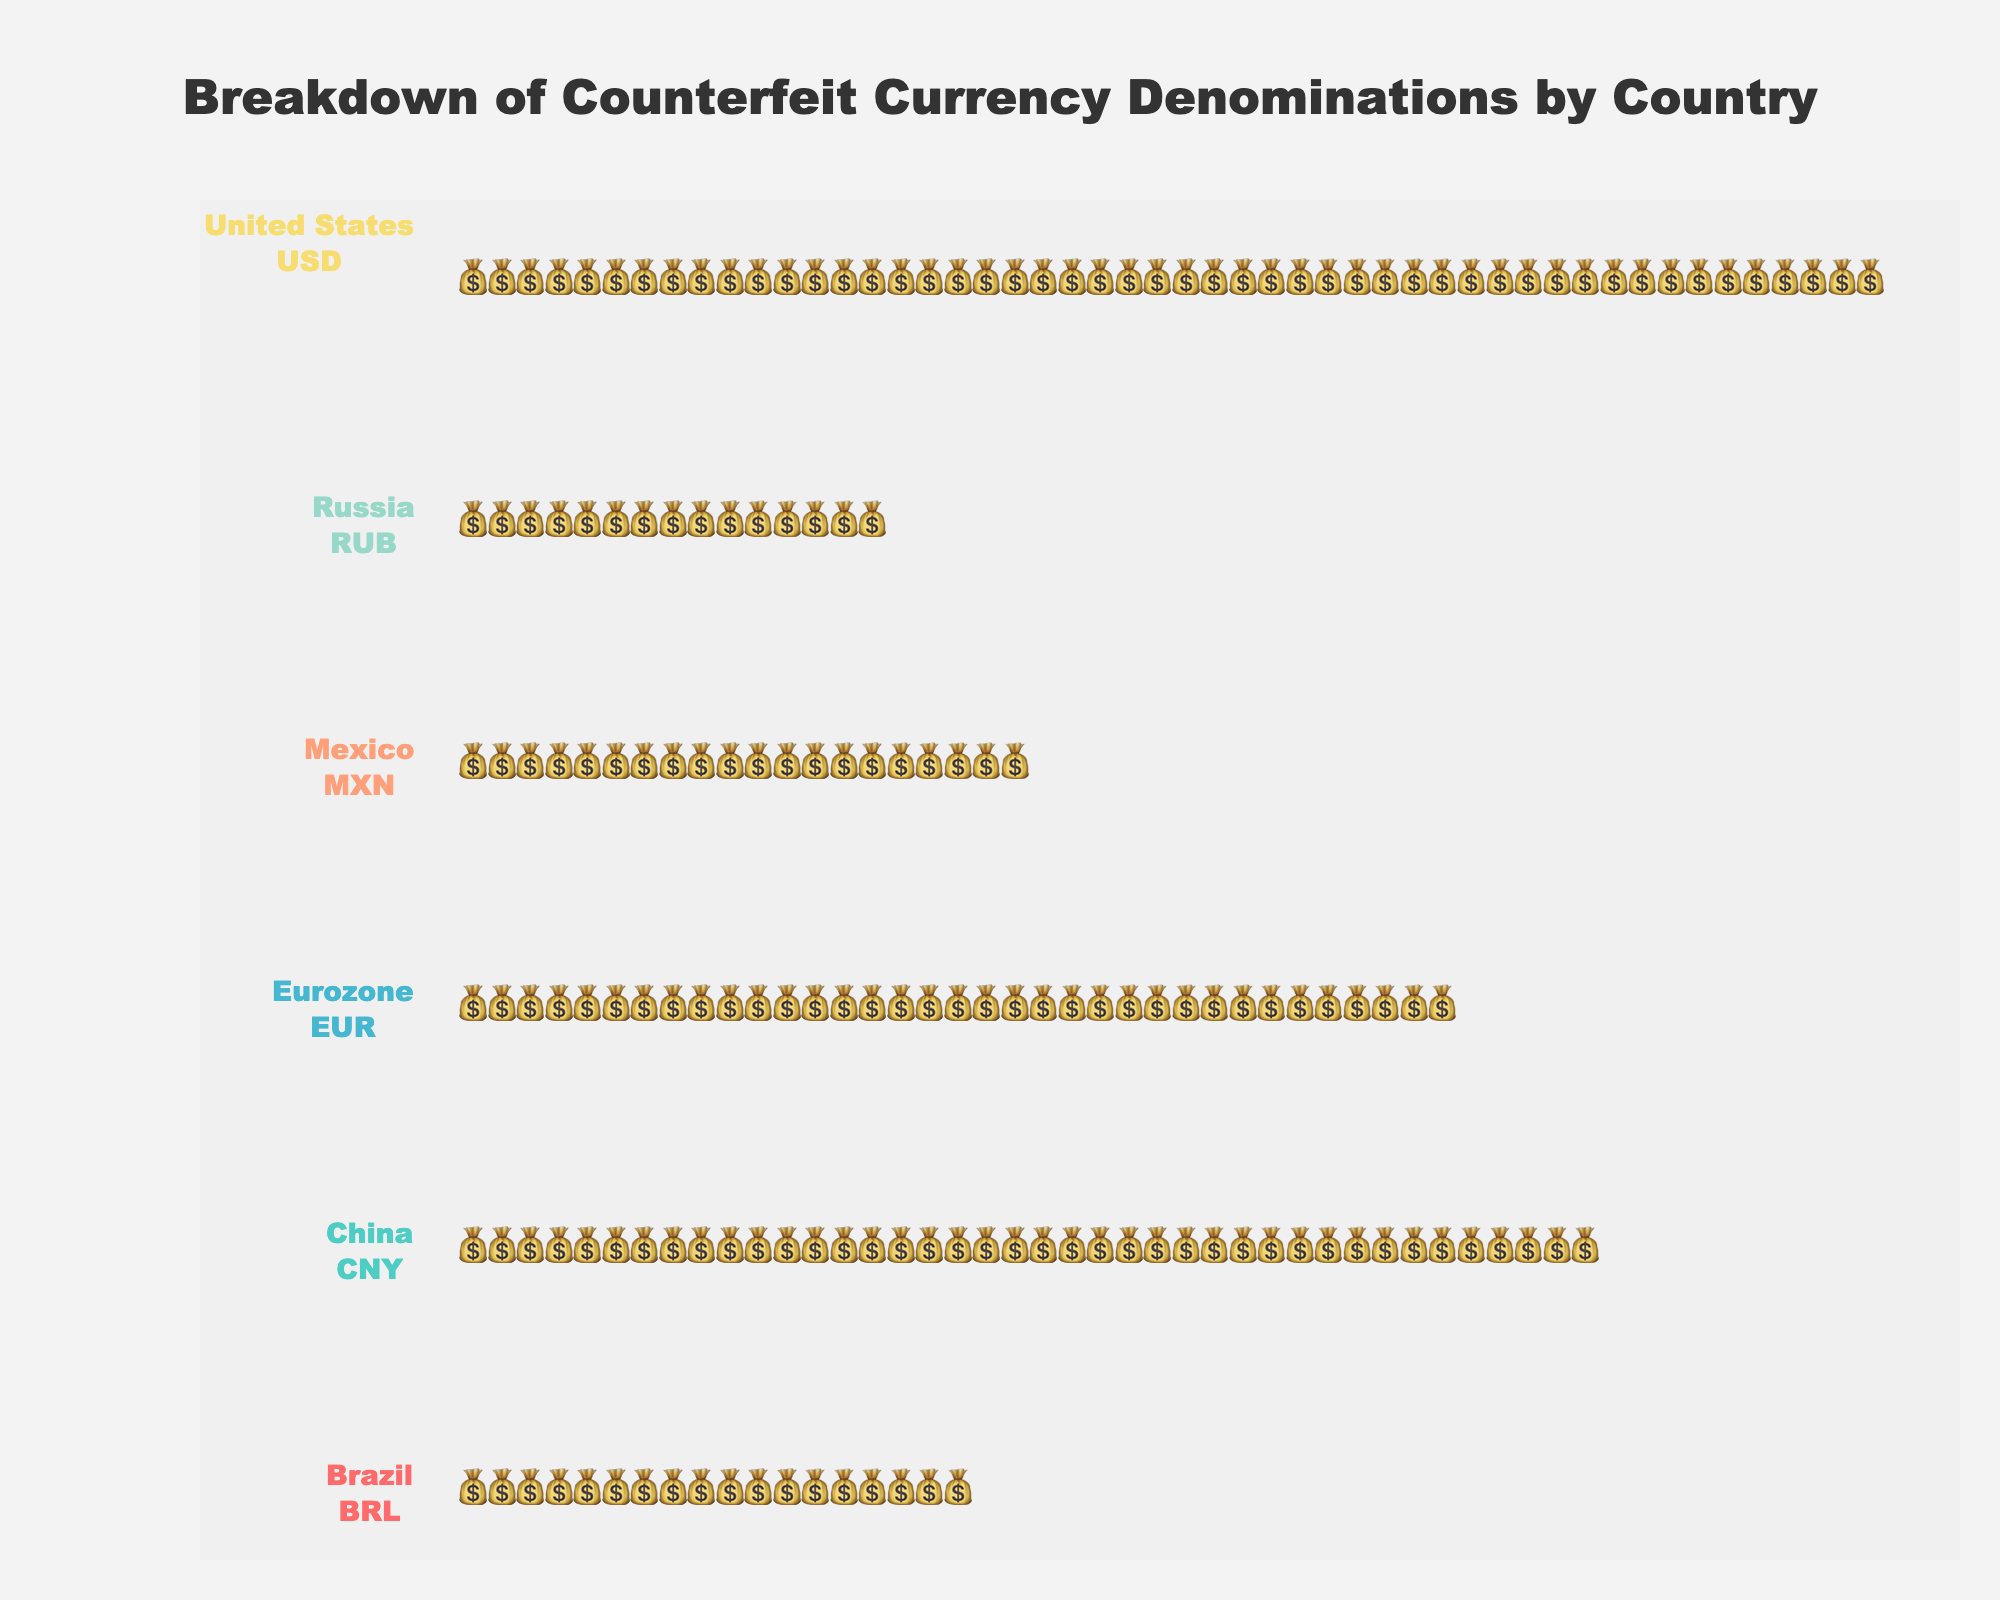What is the title of the plot? The title of the plot usually appears at the top and gives a quick overview of what the figure is about. Here, it is clearly mentioned.
Answer: Breakdown of Counterfeit Currency Denominations by Country Which country has the highest number of counterfeit 100 USD bills? To determine this, first locate the section for the United States represented by USD. Then, find the denomination labeled as 100. The visual representation of the icons (bags) indicates the quantity, which is higher for 100 denominations compared to others.
Answer: United States How many counterfeit currency denominations are depicted for China? Look for the section labeled with China (with CNY as the currency). Count the different denominations listed within this section. Each denomination is displayed with different counts of bags.
Answer: 2 Between the United States and China, which country has more counterfeit units of its largest denomination? Identify the largest denomination for each country: for the United States, it’s 100 USD, and for China, it’s 100 CNY. Compare the quantities represented by the icons (bags) for each denomination.
Answer: United States What is the combined total of counterfeit units for all denominations in Eurozone? Sum up the number of units for each denomination within the Eurozone (EUR). Specifically, observe the quantities (3500 units for 50 EUR and 2000 units for 20 EUR) and add them together.
Answer: 5500 Which country has the least number of counterfeit 1000 currency units? Identify the countries that have a 1000 denomination: Russia. Compare the number of units indicated by the icons (bags) for 1000 denominations within these countries.
Answer: Russia How many units are represented for 50 EUR in Eurozone? Look specifically at the Eurozone section (EUR) and locate the denomination labeled as 50. The number of icons will reveal the exact count.
Answer: 3500 Which country's counterfeit currency has more denominations, Mexico or Brazil? Evaluate the section for Mexico and count the denominations (500 and 200). Similarly, count the denominations for Brazil (100 and 50). Compare the counts.
Answer: It's a tie; both have 2 denominations Compare the sum of counterfeit units for 20 USD and 100 GBP. Which has more? The data shows only denominations for the United States (and no GBP data). Identify 20 USD and 100 USD quantities, sum them (3000 and 5000). As there is no GBP, state the USD sum.
Answer: 20 USD and 100 USD combined (8000) In Russia, which denomination has more counterfeit units: 5000 RUB or 1000 RUB? Look at the Russia section and locate the denominations 5000 and 1000. Compare the number of units visualized by the number of icons for these two denominations.
Answer: 5000 RUB 